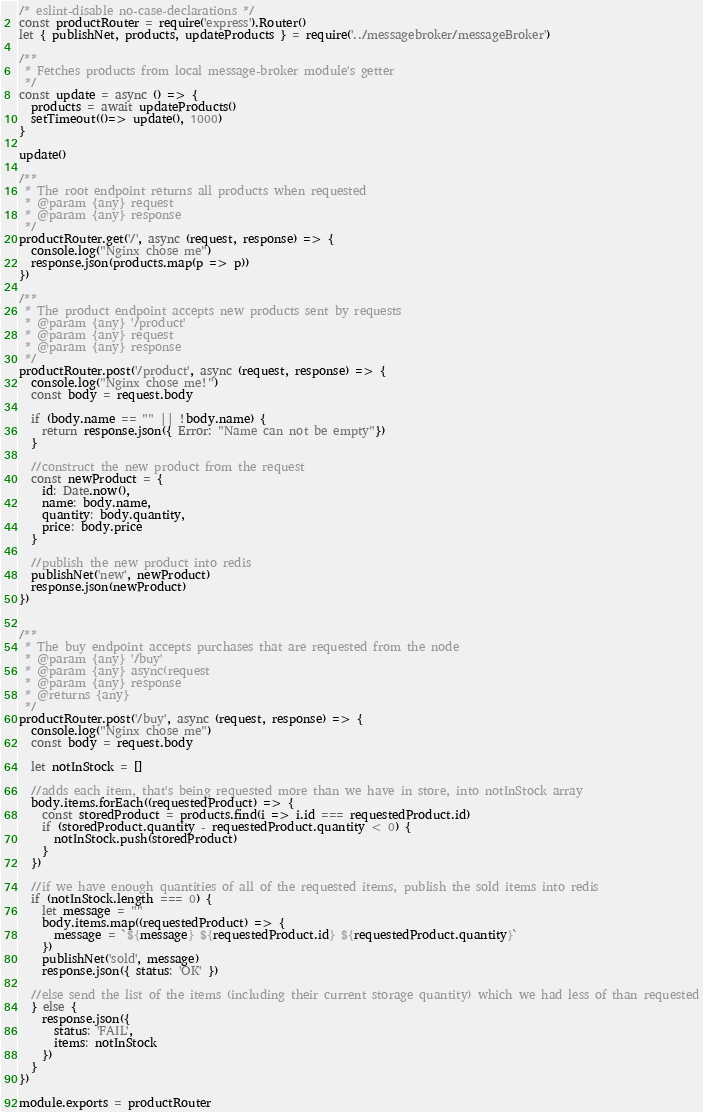Convert code to text. <code><loc_0><loc_0><loc_500><loc_500><_JavaScript_>/* eslint-disable no-case-declarations */
const productRouter = require('express').Router()
let { publishNet, products, updateProducts } = require('../messagebroker/messageBroker')

/**
 * Fetches products from local message-broker module's getter
 */
const update = async () => {
  products = await updateProducts() 
  setTimeout(()=> update(), 1000)
}

update()

/**
 * The root endpoint returns all products when requested
 * @param {any} request
 * @param {any} response
 */
productRouter.get('/', async (request, response) => {
  console.log("Nginx chose me")
  response.json(products.map(p => p))
})

/**
 * The product endpoint accepts new products sent by requests
 * @param {any} '/product'
 * @param {any} request
 * @param {any} response
 */
productRouter.post('/product', async (request, response) => {
  console.log("Nginx chose me!")
  const body = request.body

  if (body.name == "" || !body.name) {
    return response.json({ Error: "Name can not be empty"})
  }

  //construct the new product from the request
  const newProduct = {
    id: Date.now(),
    name: body.name,
    quantity: body.quantity,
    price: body.price
  }

  //publish the new product into redis
  publishNet('new', newProduct)
  response.json(newProduct)
})


/**
 * The buy endpoint accepts purchases that are requested from the node
 * @param {any} '/buy'
 * @param {any} async(request
 * @param {any} response
 * @returns {any}
 */
productRouter.post('/buy', async (request, response) => {
  console.log("Nginx chose me")
  const body = request.body

  let notInStock = []

  //adds each item, that's being requested more than we have in store, into notInStock array 
  body.items.forEach((requestedProduct) => {
    const storedProduct = products.find(i => i.id === requestedProduct.id)
    if (storedProduct.quantity - requestedProduct.quantity < 0) {
      notInStock.push(storedProduct)
    }
  })

  //if we have enough quantities of all of the requested items, publish the sold items into redis
  if (notInStock.length === 0) {
    let message = ""
    body.items.map((requestedProduct) => {
      message = `${message} ${requestedProduct.id} ${requestedProduct.quantity}`
    })
    publishNet('sold', message)
    response.json({ status: 'OK' })

  //else send the list of the items (including their current storage quantity) which we had less of than requested
  } else {
    response.json({
      status: 'FAIL',
      items: notInStock
    })
  }
})

module.exports = productRouter</code> 